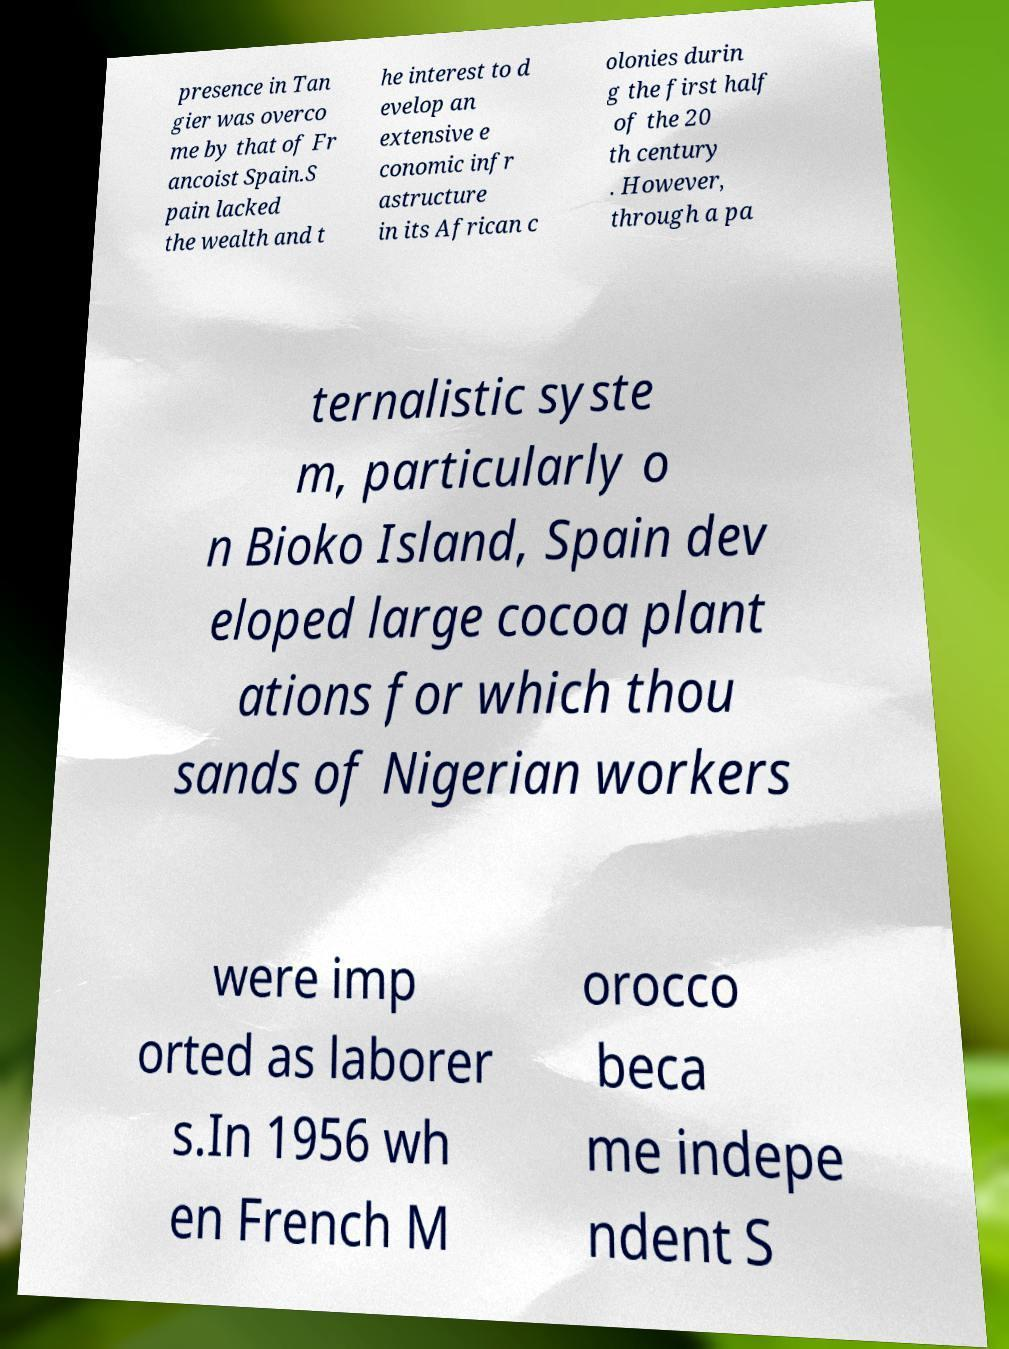What messages or text are displayed in this image? I need them in a readable, typed format. presence in Tan gier was overco me by that of Fr ancoist Spain.S pain lacked the wealth and t he interest to d evelop an extensive e conomic infr astructure in its African c olonies durin g the first half of the 20 th century . However, through a pa ternalistic syste m, particularly o n Bioko Island, Spain dev eloped large cocoa plant ations for which thou sands of Nigerian workers were imp orted as laborer s.In 1956 wh en French M orocco beca me indepe ndent S 